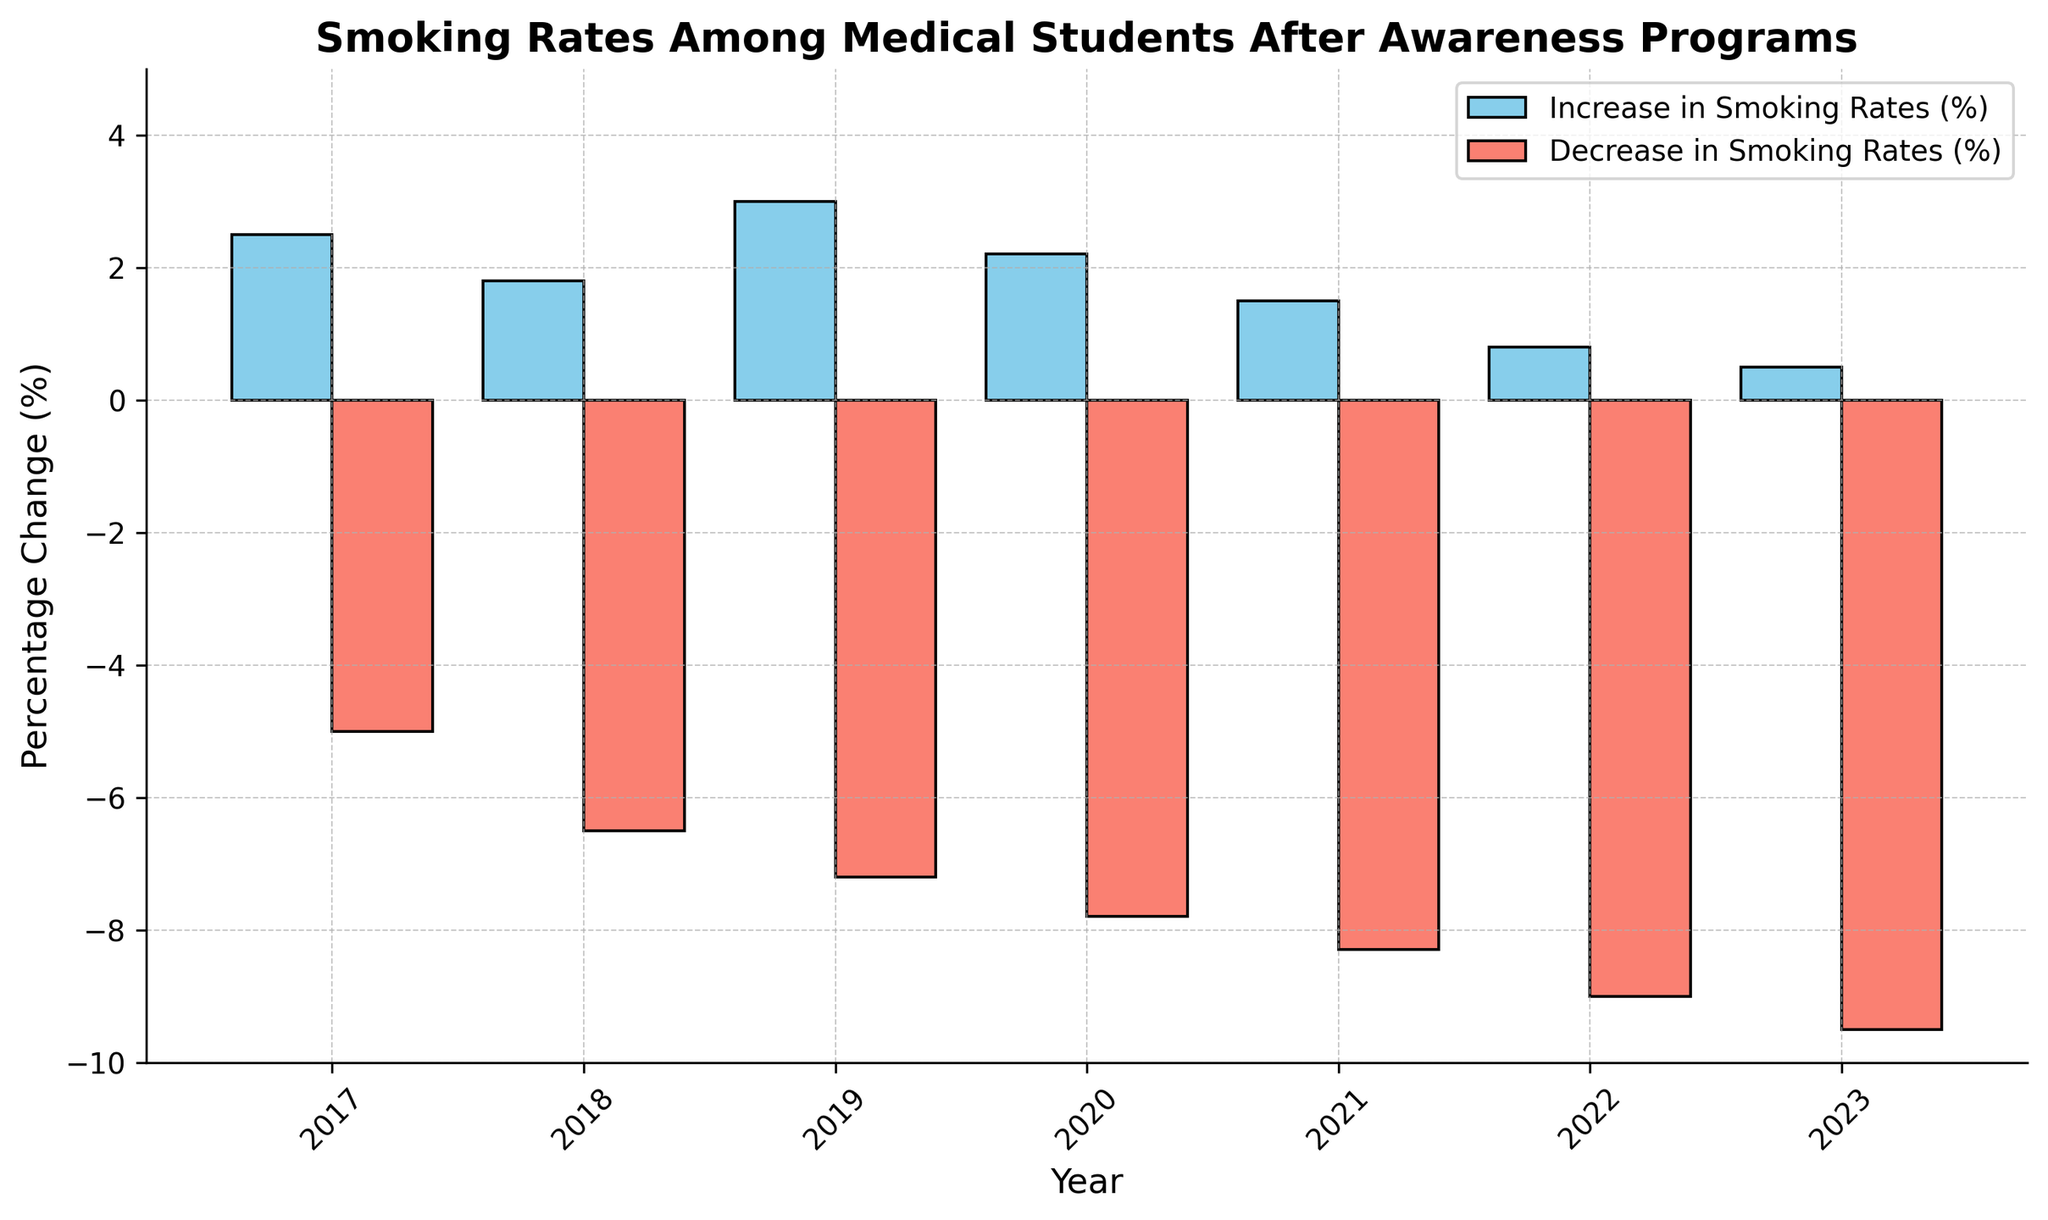How does the overall trend of the increase in smoking rates change from 2017 to 2023? The increase in smoking rates shows a decreasing trend over the years. Starting from 2.5% in 2017, it progressively declines to 0.5% by 2023.
Answer: Decreasing What is the difference between the highest and the lowest decrease in smoking rates? The highest decrease in smoking rates is 9.5% in 2023, and the lowest is 5.0% in 2017. The difference is 9.5 - 5.0 = 4.5%.
Answer: 4.5% Between which years was the decrease in smoking rates the highest? The decrease in smoking rates increases consistently year over year. However, the largest single-year increase in the decrease of smoking rates appears between 2019 (7.2%) and 2020 (7.8%), reflecting an increase of 0.6%.
Answer: 2019 to 2020 In which year did the smoking rates witness the smallest increase? The smallest increase in smoking rates occurred in 2023, where the increase was only 0.5%.
Answer: 2023 How does the color of the bars help in distinguishing the rates? The bars representing the increase in smoking rates are colored sky blue, while the bars for the decrease in smoking rates are colored salmon. This visual distinction makes it easy to differentiate between the types of rate changes.
Answer: Sky blue for increase, salmon for decrease What can you infer from the general trend in decrease rates from 2017 to 2023? There is a consistent increase in the percentage of decrease rates each year, moving from 5.0% in 2017 to 9.5% in 2023, indicating the awareness programs' increasing effectiveness over time.
Answer: Increasing effectiveness Which year had the largest decrease in smoking rates compared to the previous year? The largest rate of decrease compared to the previous year occurred from 2020 to 2021, where the decrease rate jumped from 7.8% to 8.3%, a change of 0.5%.
Answer: 2020 to 2021 What is the overall difference in the smoking rates (considering both increase and decrease) from 2017 to 2023? In 2017, the increase is 2.5% and the decrease is 5.0%. In 2023, the increase is 0.5% and the decrease is 9.5%. The overall change is (0.5 - 2.5) + (9.5 - 5.0) = -2.0 + 4.5 = 2.5%.
Answer: 2.5% 